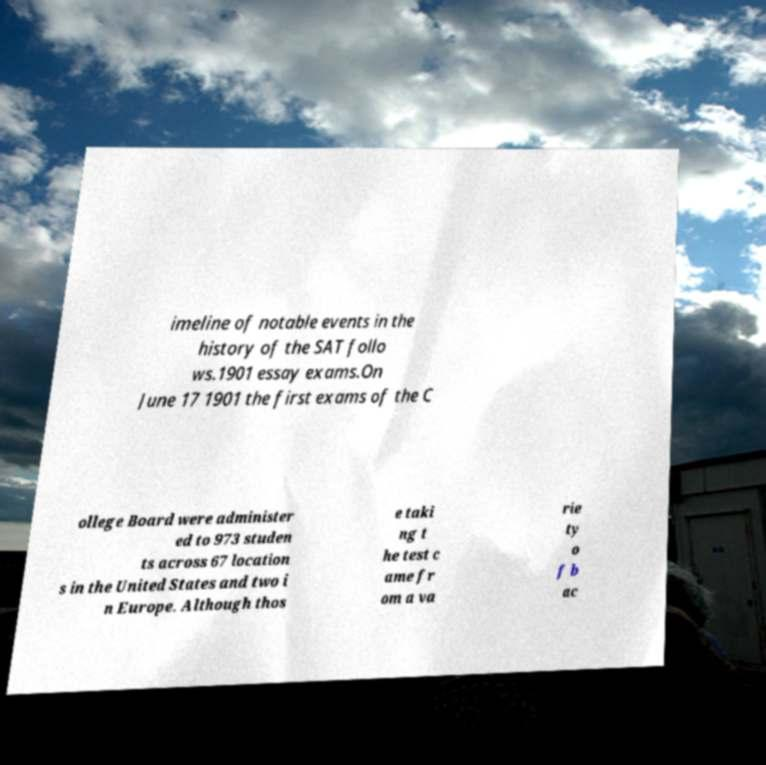Please read and relay the text visible in this image. What does it say? imeline of notable events in the history of the SAT follo ws.1901 essay exams.On June 17 1901 the first exams of the C ollege Board were administer ed to 973 studen ts across 67 location s in the United States and two i n Europe. Although thos e taki ng t he test c ame fr om a va rie ty o f b ac 